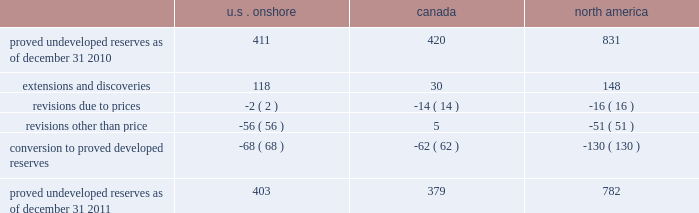Devon energy corporation and subsidiaries notes to consolidated financial statements 2014 ( continued ) proved undeveloped reserves the table presents the changes in our total proved undeveloped reserves during 2011 ( in mmboe ) . .
At december 31 , 2011 , devon had 782 mmboe of proved undeveloped reserves .
This represents a 6% ( 6 % ) decrease as compared to 2010 and represents 26% ( 26 % ) of its total proved reserves .
Drilling activities increased devon 2019s proved undeveloped reserves 148 mmboe and resulted in the conversion of 130 mmboe , or 16% ( 16 % ) , of the 2010 proved undeveloped reserves to proved developed reserves .
Additionally , revisions other than price decreased devon 2019s proved undeveloped reserves 51 mmboe primarily due to its evaluation of certain u.s .
Onshore dry-gas areas , which it does not expect to develop in the next five years .
The largest revisions relate to the dry-gas areas at carthage in east texas and the barnett shale in north texas .
A significant amount of devon 2019s proved undeveloped reserves at the end of 2011 largely related to its jackfish operations .
At december 31 , 2011 and 2010 , devon 2019s jackfish proved undeveloped reserves were 367 mmboe and 396 mmboe , respectively .
Development schedules for the jackfish reserves are primarily controlled by the need to keep the processing plants at their 35000 barrel daily facility capacity .
Processing plant capacity is controlled by factors such as total steam processing capacity , steam-oil ratios and air quality discharge permits .
As a result , these reserves are classified as proved undeveloped for more than five years .
Currently , the development schedule for these reserves extends though the year 2025 .
Price revisions 2011 2014reserves decreased 21 mmboe due to lower gas prices and higher oil prices .
The higher oil prices increased devon 2019s canadian royalty burden , which reduced devon 2019s oil reserves .
2010 2014reserves increased 72 mmboe due to higher gas prices , partially offset by the effect of higher oil prices .
The higher oil prices increased devon 2019s canadian royalty burden , which reduced devon 2019s oil reserves .
Of the 72 mmboe price revisions , 43 mmboe related to the barnett shale and 22 mmboe related to the rocky mountain area .
2009 2014reserves increased 177 mmboe due to higher oil prices , partially offset by lower gas prices .
The increase in oil reserves primarily related to devon 2019s jackfish thermal heavy oil reserves in canada .
At the end of 2008 , 331 mmboe of reserves related to jackfish were not considered proved .
However , due to higher prices , these reserves were considered proved as of december 31 , 2009 .
Significantly lower gas prices caused devon 2019s reserves to decrease 116 mmboe , which primarily related to its u.s .
Reserves .
Revisions other than price total revisions other than price for 2011 primarily related to devon 2019s evaluation of certain dry gas regions noted in the proved undeveloped reserves discussion above .
Total revisions other than price for 2010 and 2009 primarily related to devon 2019s drilling and development in the barnett shale. .
What was the percentage change in total proved undeveloped reserves for canada from 2010 to 2011? 
Computations: ((379 - 420) / 420)
Answer: -0.09762. 